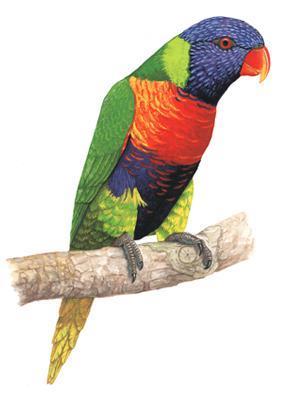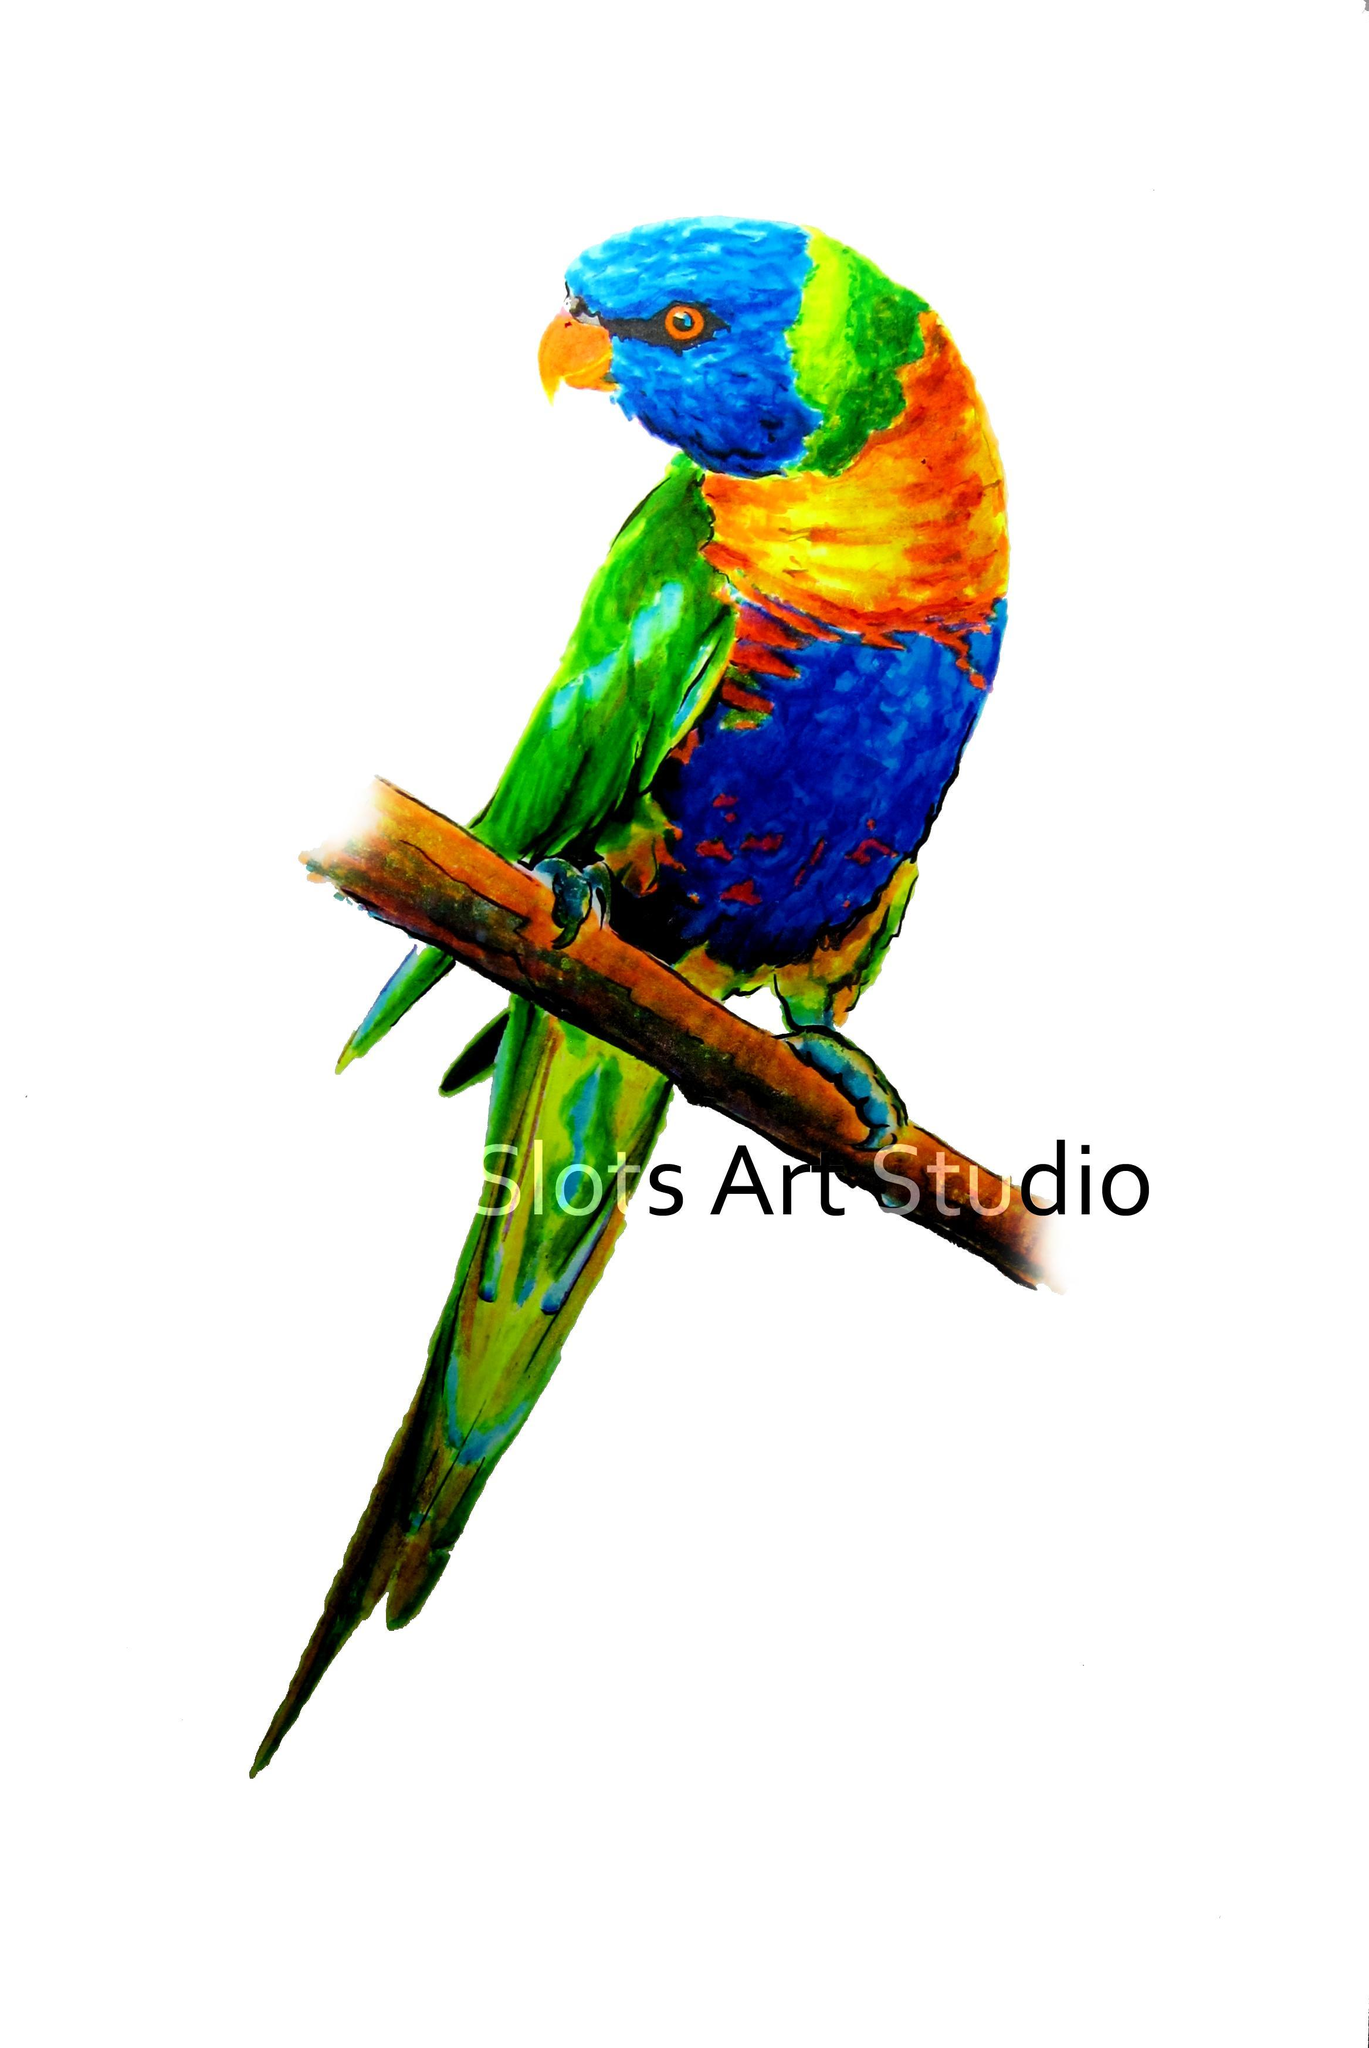The first image is the image on the left, the second image is the image on the right. For the images displayed, is the sentence "The parrots in the two images are looking toward each other." factually correct? Answer yes or no. Yes. The first image is the image on the left, the second image is the image on the right. Examine the images to the left and right. Is the description "A single bird perches on a branch with leaves on it." accurate? Answer yes or no. No. 